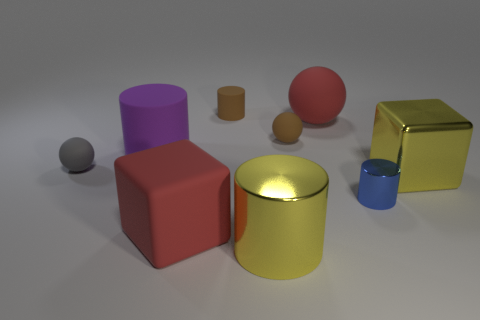What materials do the objects seem to be made out of? The objects exhibit various textures suggesting different materials. The gray and purple objects have a matte finish implying a non-reflective, possibly plastic material. The blue and orange cylinders have a similar sheen and may be made of a painted metal. The red cube appears solid and matte, hinting at a clay or matte painted wood. Finally, the golden cube has a reflective metallic finish, suggesting it is either gold-plated or made of a polished metal to give it that luxurious shine. 